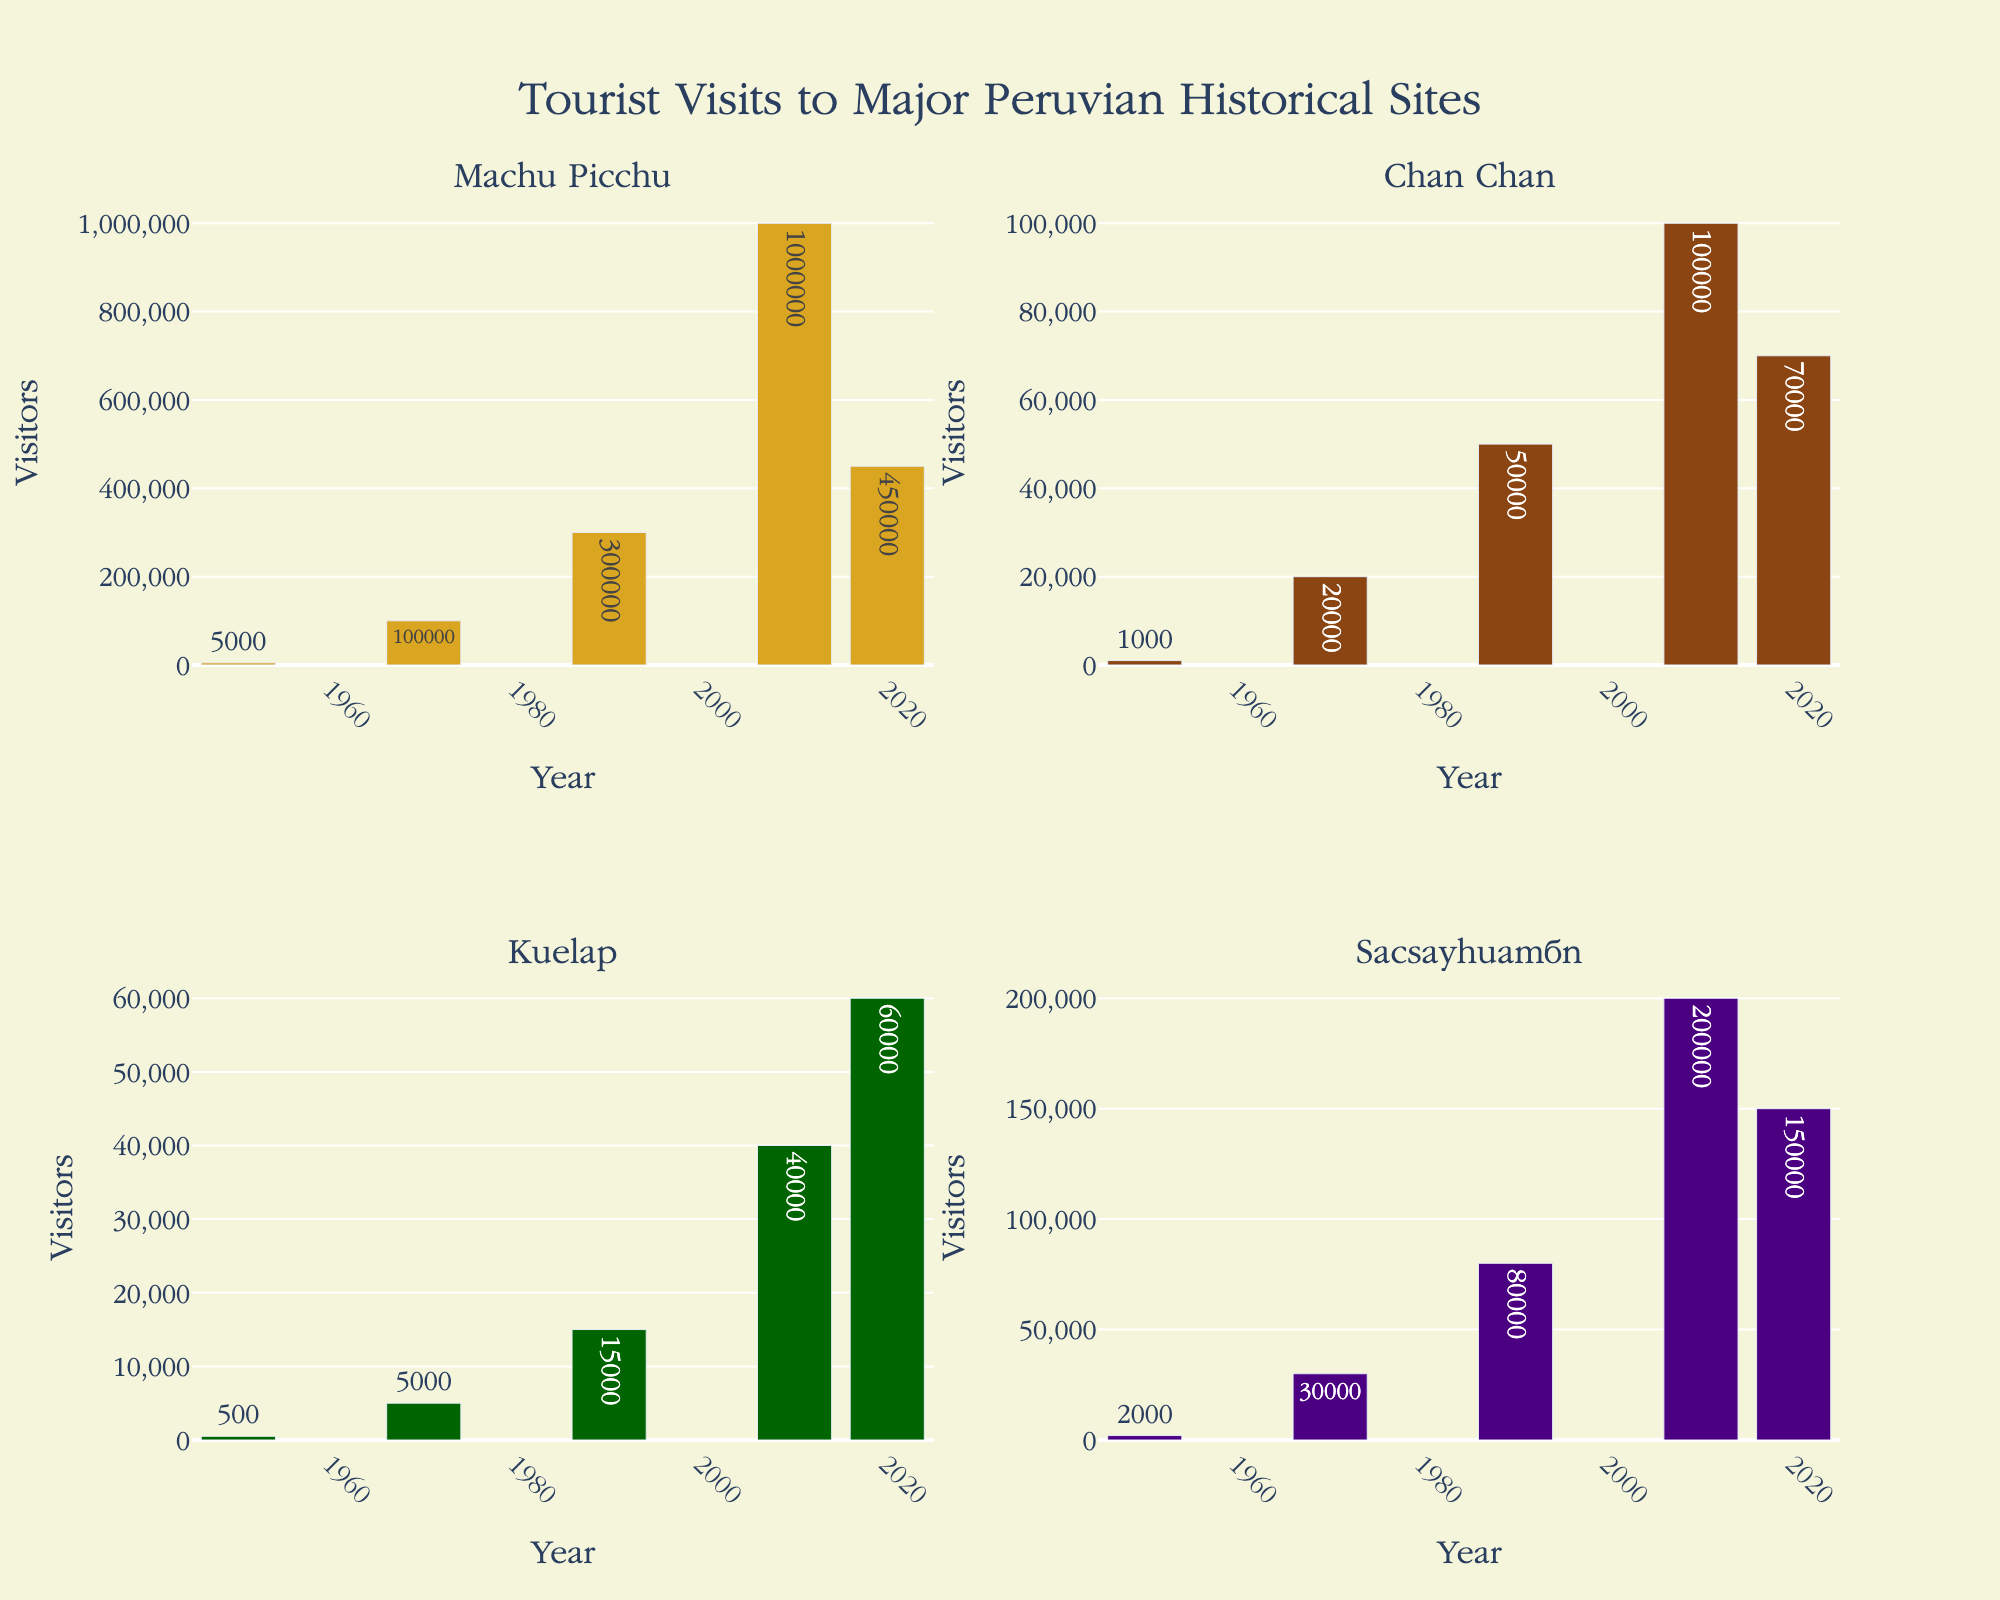What is the title of the figure? The title is usually displayed prominently at the top of the figure. In this case, look at the text at the top-center of the chart.
Answer: Tourist Visits to Major Peruvian Historical Sites Which historical site had the highest number of visitors in 2010? Find the 2010 bar height for each subplot and identify which one is the tallest.
Answer: Machu Picchu How many visitors did Sacsayhuamán attract in 1990? Locate the subplot labeled Sacsayhuamán, find the bar corresponding to 1990, and read the height/label of the bar
Answer: 80,000 What is the difference in the number of visitors to Machu Picchu between 1990 and 2020? Find the visitors in 1990 and 2020 from the Machu Picchu subplot and subtract the 1990 value from the 2020 value.
Answer: 150,000 Which site had the least amount of visitors in 1950? Check the height of the bars for all sites in 1950 and identify the smallest one.
Answer: Kuelap What is the average number of visitors to Chan Chan in 1970 and 2020? Find the visitor counts in 1970 and 2020 for Chan Chan, add them together, and divide by 2.
Answer: 45,000 How many visitors did Kuelap have in total from 1950 to 2020? Sum the number of visitors for Kuelap across all the years shown in its subplot.
Answer: 120,500 Compare the increase in visitors from 1950 to 2020 between Machu Picchu and Sacsayhuamán. Which site had a bigger increase? Calculate the difference between 2020 and 1950 visitor counts for both Machu Picchu and Sacsayhuamán, then compare the differences.
Answer: Machu Picchu What was the average number of visitors per year for Machu Picchu during the period shown? Sum the number of visitors across all years for Machu Picchu and divide by the number of years (5).
Answer: 371,000 